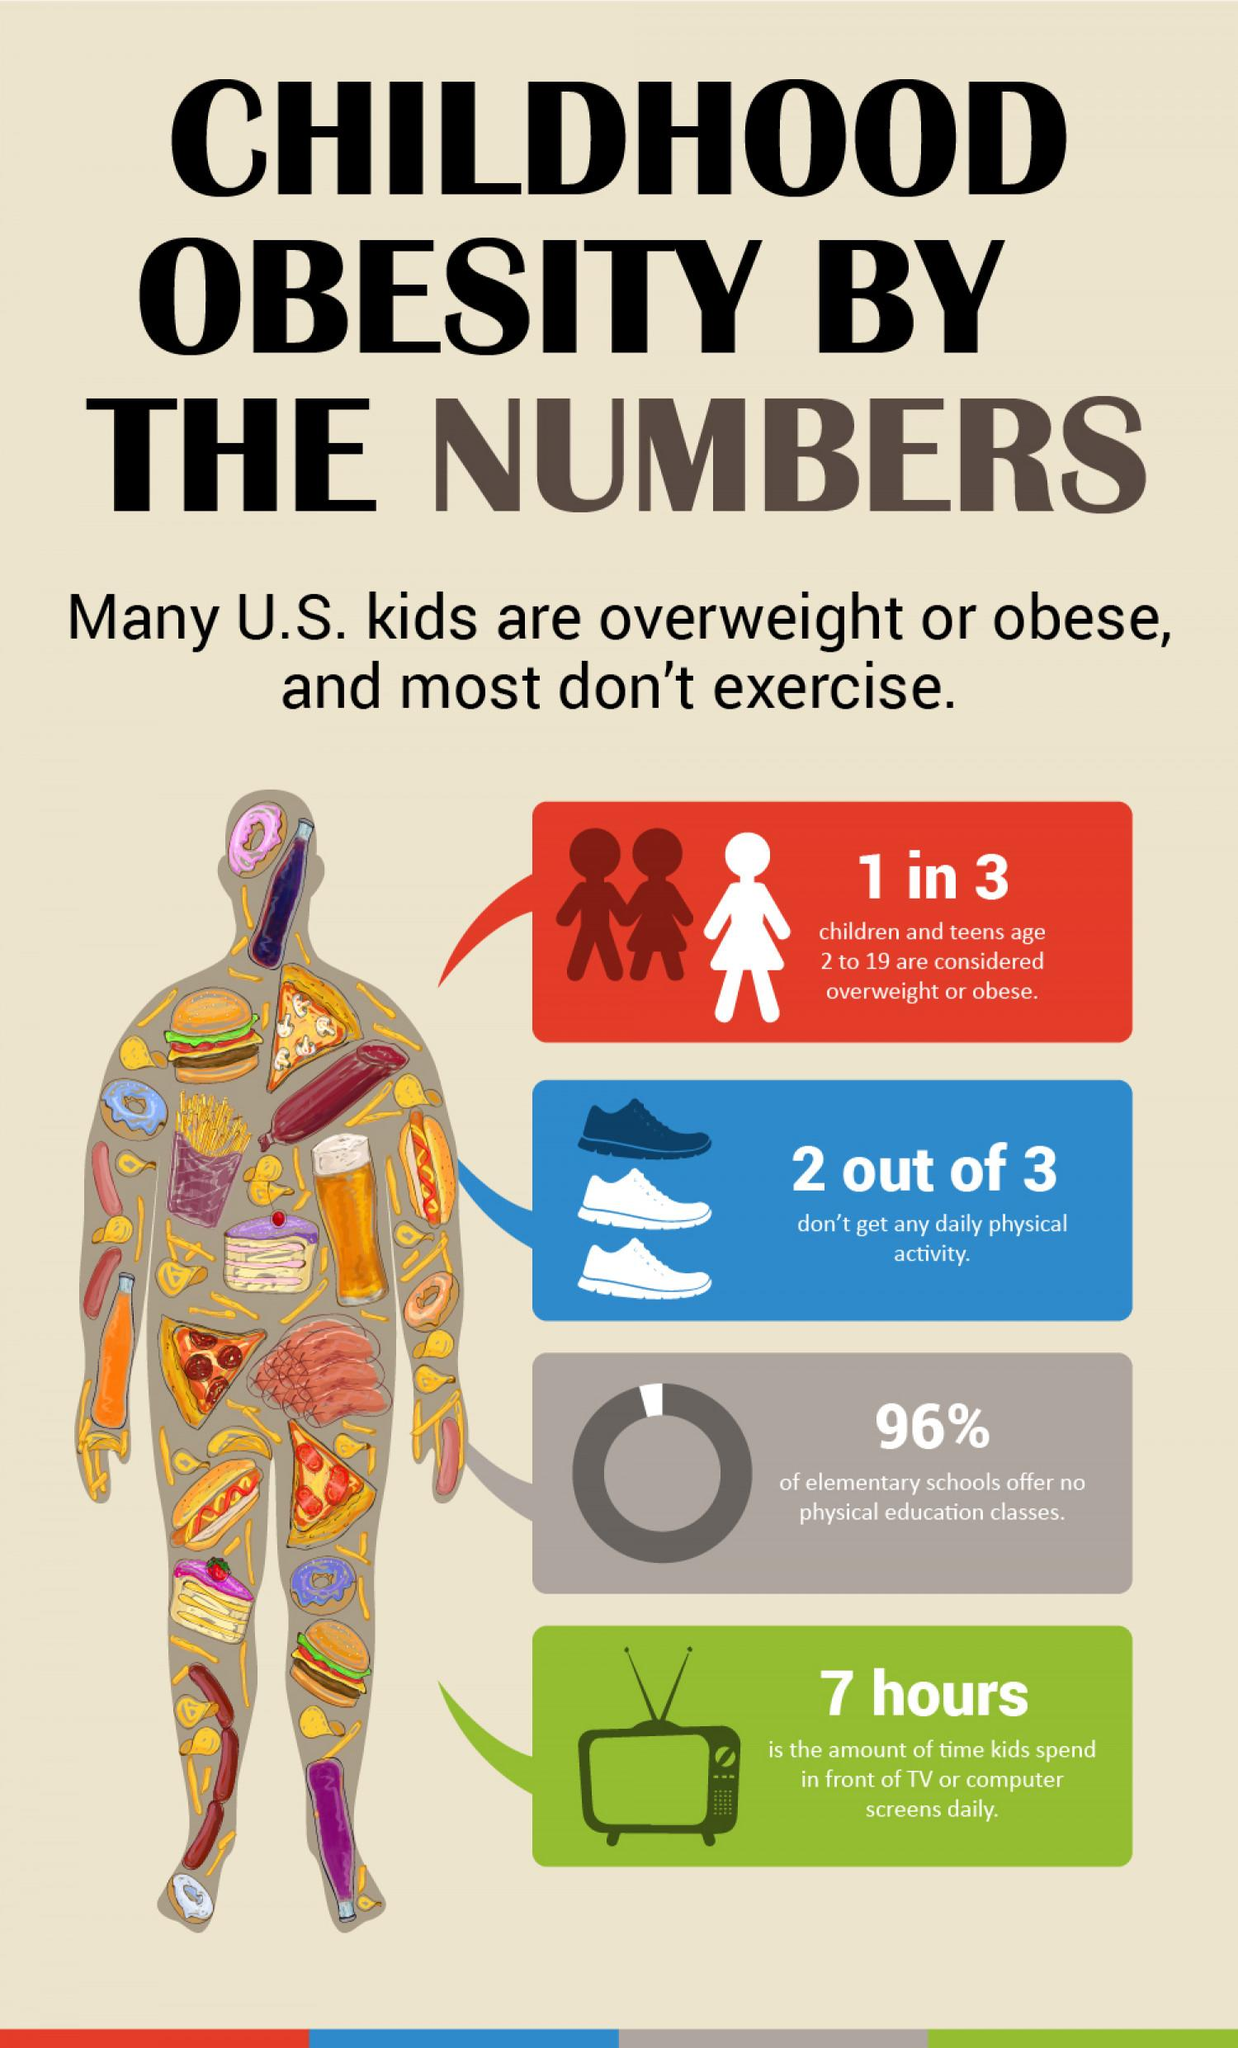Outline some significant characteristics in this image. The picture shows a radio, washer, television, or computer, and in the green colored box at the bottom, the electronic appliance is a television. In the photo, the man's figure is depicted with a plethora of colors, shapes, and junk food. Specifically, junk food can be seen prominently featured in the image. According to recent data, only 4% of elementary schools in the United States offer physical education classes. 